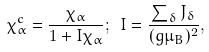<formula> <loc_0><loc_0><loc_500><loc_500>\chi _ { \alpha } ^ { c } = \frac { \chi _ { \alpha } } { 1 + I \chi _ { \alpha } } ; \text { } I = \frac { \sum _ { \delta } J _ { \delta } } { ( g \mu _ { B } ) ^ { 2 } } ,</formula> 